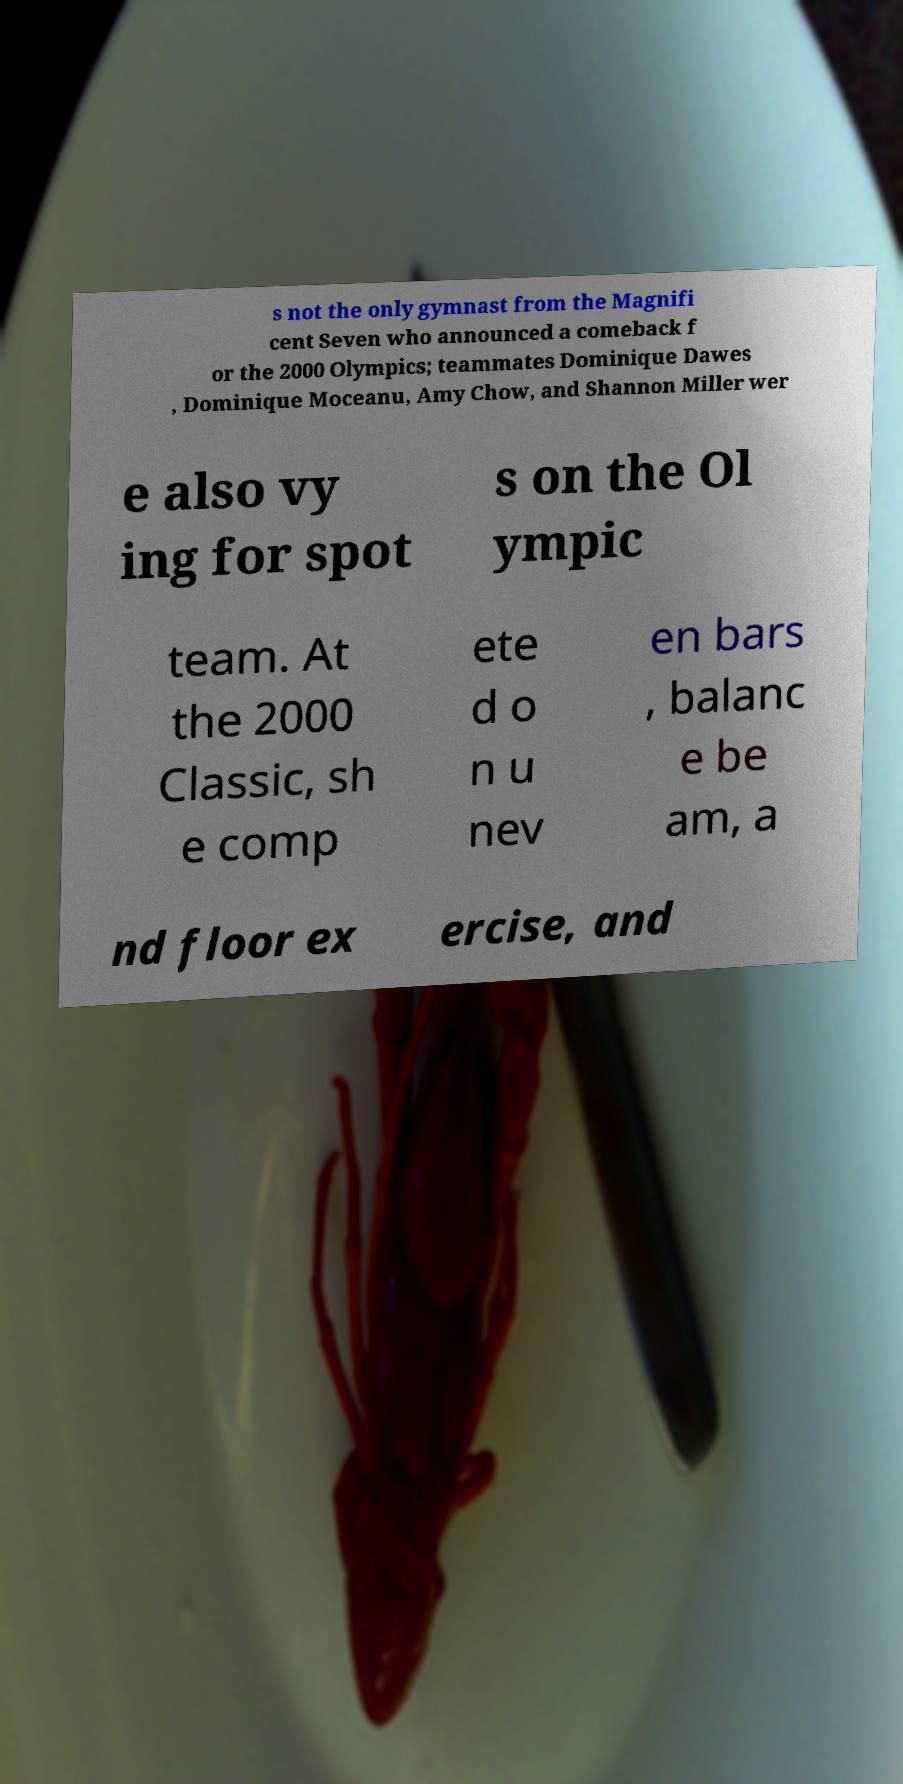Can you read and provide the text displayed in the image?This photo seems to have some interesting text. Can you extract and type it out for me? s not the only gymnast from the Magnifi cent Seven who announced a comeback f or the 2000 Olympics; teammates Dominique Dawes , Dominique Moceanu, Amy Chow, and Shannon Miller wer e also vy ing for spot s on the Ol ympic team. At the 2000 Classic, sh e comp ete d o n u nev en bars , balanc e be am, a nd floor ex ercise, and 